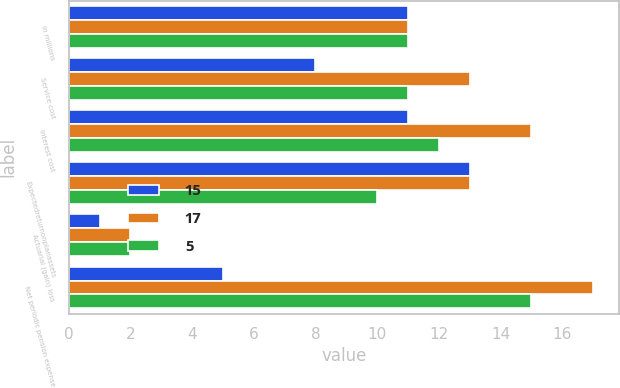Convert chart to OTSL. <chart><loc_0><loc_0><loc_500><loc_500><stacked_bar_chart><ecel><fcel>In millions<fcel>Service cost<fcel>Interest cost<fcel>Expectedreturnonplanassets<fcel>Actuarial (gain) loss<fcel>Net periodic pension expense<nl><fcel>15<fcel>11<fcel>8<fcel>11<fcel>13<fcel>1<fcel>5<nl><fcel>17<fcel>11<fcel>13<fcel>15<fcel>13<fcel>2<fcel>17<nl><fcel>5<fcel>11<fcel>11<fcel>12<fcel>10<fcel>2<fcel>15<nl></chart> 